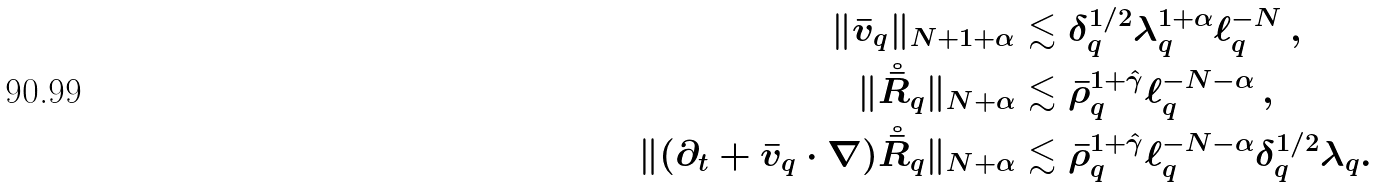Convert formula to latex. <formula><loc_0><loc_0><loc_500><loc_500>\| \bar { v } _ { q } \| _ { N + 1 + \alpha } & \lesssim \delta _ { q } ^ { 1 / 2 } \lambda _ { q } ^ { 1 + \alpha } \ell _ { q } ^ { - N } \, , \\ \| { \mathring { \bar { R } } _ { q } } \| _ { N + \alpha } & \lesssim \bar { \rho } _ { q } ^ { 1 + { \hat { \gamma } } } \ell _ { q } ^ { - N - \alpha } \, , \\ \| ( \partial _ { t } + \bar { v } _ { q } \cdot \nabla ) \mathring { \bar { R } } _ { q } \| _ { N + \alpha } & \lesssim \bar { \rho } _ { q } ^ { 1 + { \hat { \gamma } } } \ell _ { q } ^ { - N - \alpha } \delta _ { q } ^ { 1 / 2 } \lambda _ { q } .</formula> 